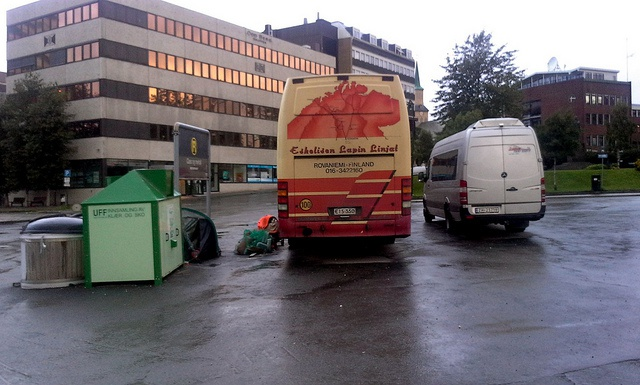Describe the objects in this image and their specific colors. I can see bus in white, maroon, gray, brown, and tan tones, truck in white, darkgray, black, gray, and lightgray tones, bus in white, darkgray, black, gray, and lightgray tones, bench in black and white tones, and bench in black and white tones in this image. 